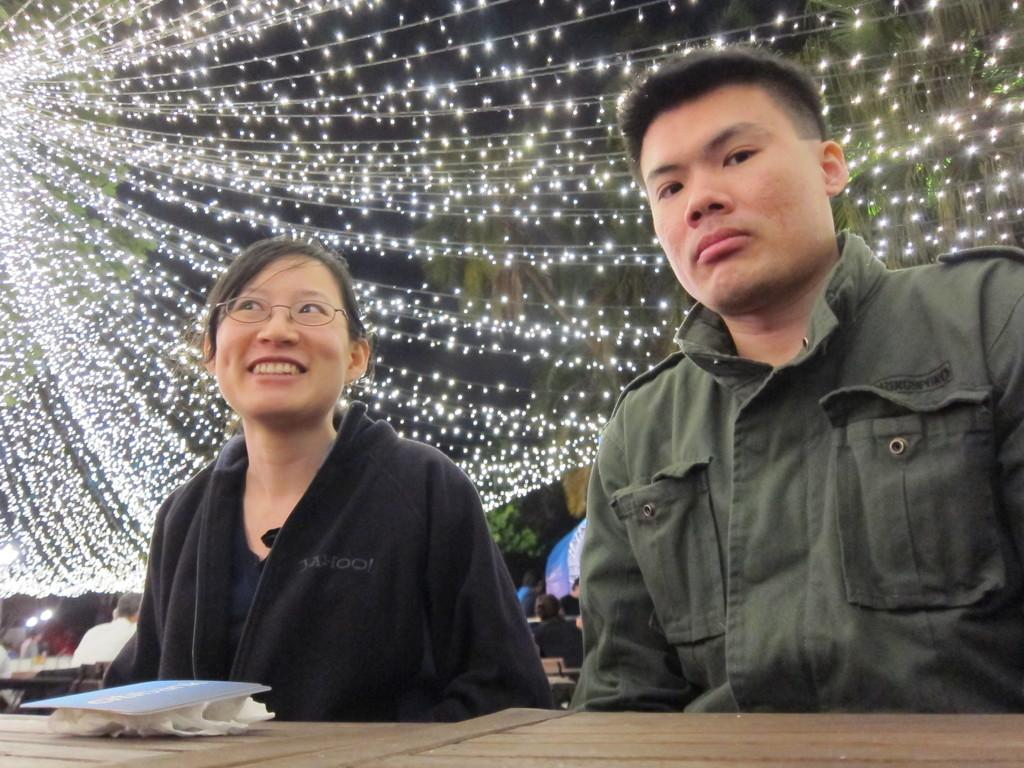How many people are sitting in the image? There are two persons sitting in the image. What can be seen in the image besides the people? There are lights and other objects visible in the image. What type of coat is the person wearing in the image? There is no coat visible in the image; the persons are not wearing any outerwear. 